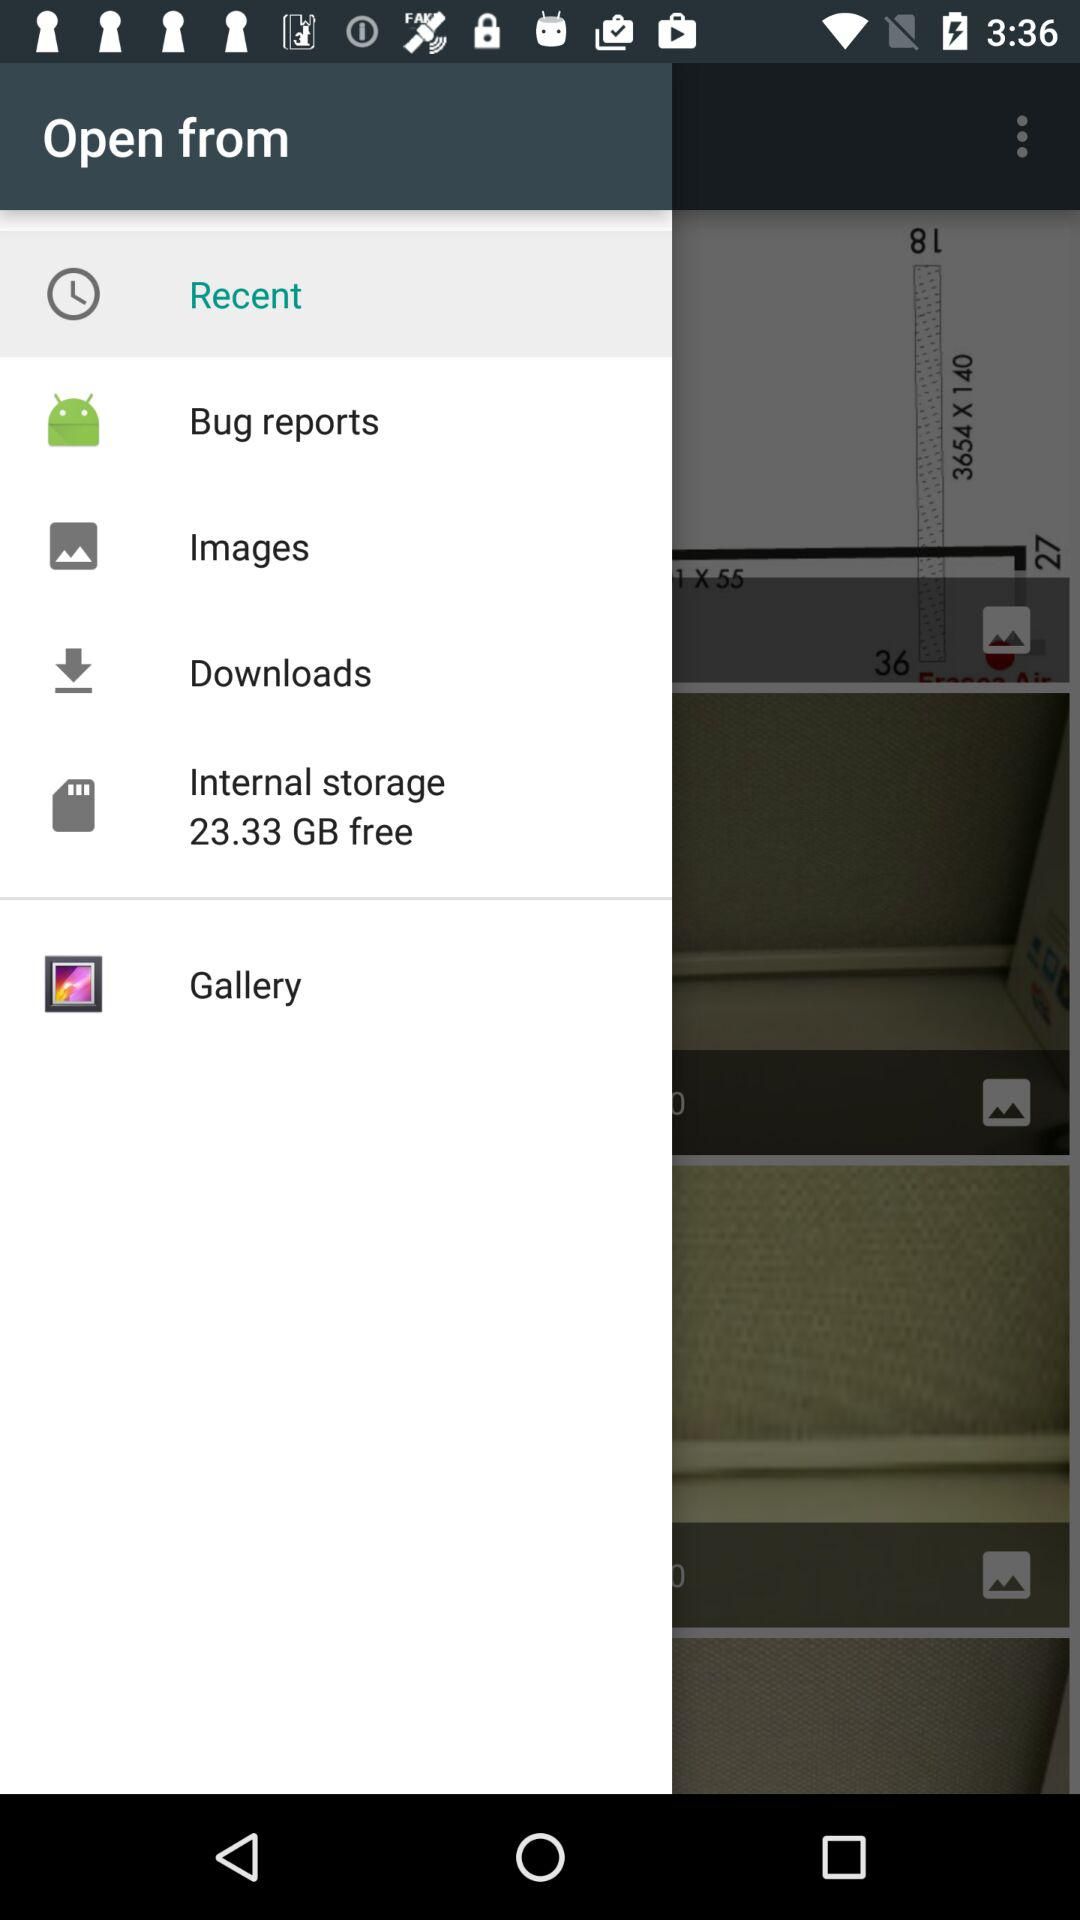Which item is selected? The selected item is "Recent". 